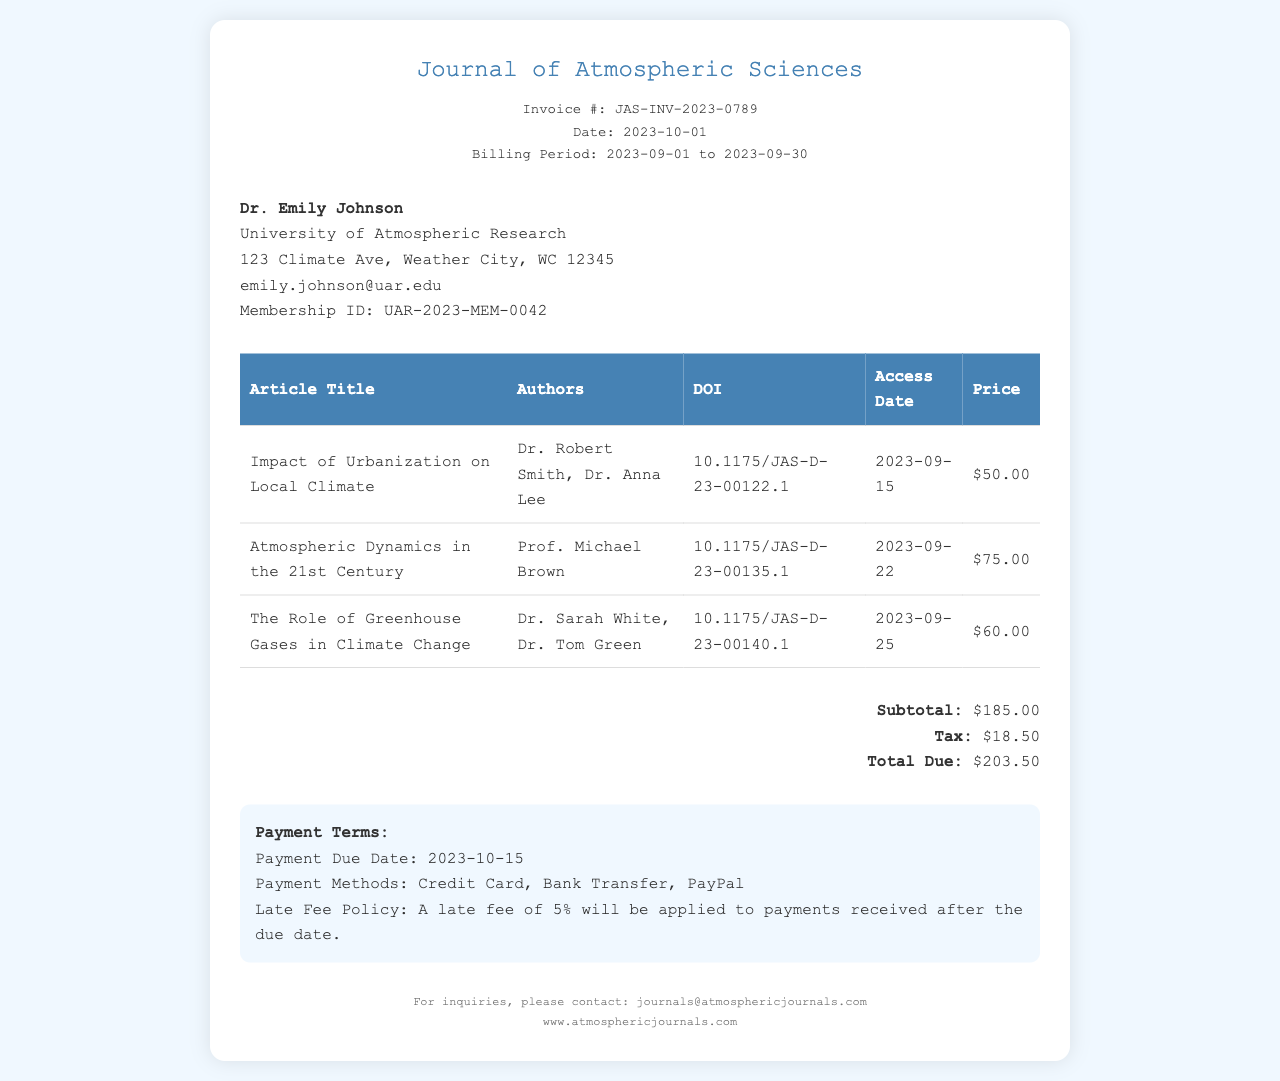What is the invoice number? The invoice number is specified in the document as a unique identifier for the invoice.
Answer: JAS-INV-2023-0789 Who is the subscriber? The subscriber's name is provided in the document, referring to the individual who holds the subscription.
Answer: Dr. Emily Johnson What is the total amount due? The total amount due is calculated from the subtotal and tax provided in the invoice, representing the final cost.
Answer: $203.50 What is the due date for payment? The due date for payment is mentioned in the payment terms, indicating when the payment must be completed.
Answer: 2023-10-15 How many articles were accessed? The number of articles accessed can be determined by counting the entries in the article table section of the invoice.
Answer: 3 What was the price of the article "Atmospheric Dynamics in the 21st Century"? This article's specific price is listed in the table and represents its individual access cost.
Answer: $75.00 What payment methods are accepted? The document lists the payment methods available for settling the invoice, which are relevant for subscribers.
Answer: Credit Card, Bank Transfer, PayPal What is the late fee percentage? The late fee policy specifies a percentage to be applied for late payments, indicating the penalty for overdue invoices.
Answer: 5% 